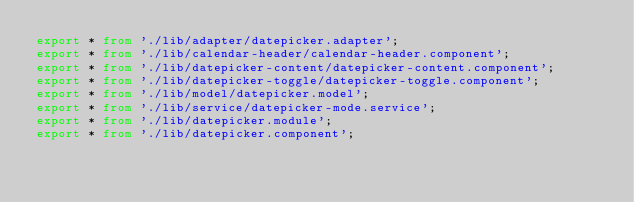Convert code to text. <code><loc_0><loc_0><loc_500><loc_500><_TypeScript_>export * from './lib/adapter/datepicker.adapter';
export * from './lib/calendar-header/calendar-header.component';
export * from './lib/datepicker-content/datepicker-content.component';
export * from './lib/datepicker-toggle/datepicker-toggle.component';
export * from './lib/model/datepicker.model';
export * from './lib/service/datepicker-mode.service';
export * from './lib/datepicker.module';
export * from './lib/datepicker.component';
</code> 